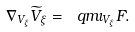<formula> <loc_0><loc_0><loc_500><loc_500>\nabla _ { V _ { \xi } } \widetilde { V } _ { \xi } = \ q m \iota _ { V _ { \xi } } F .</formula> 